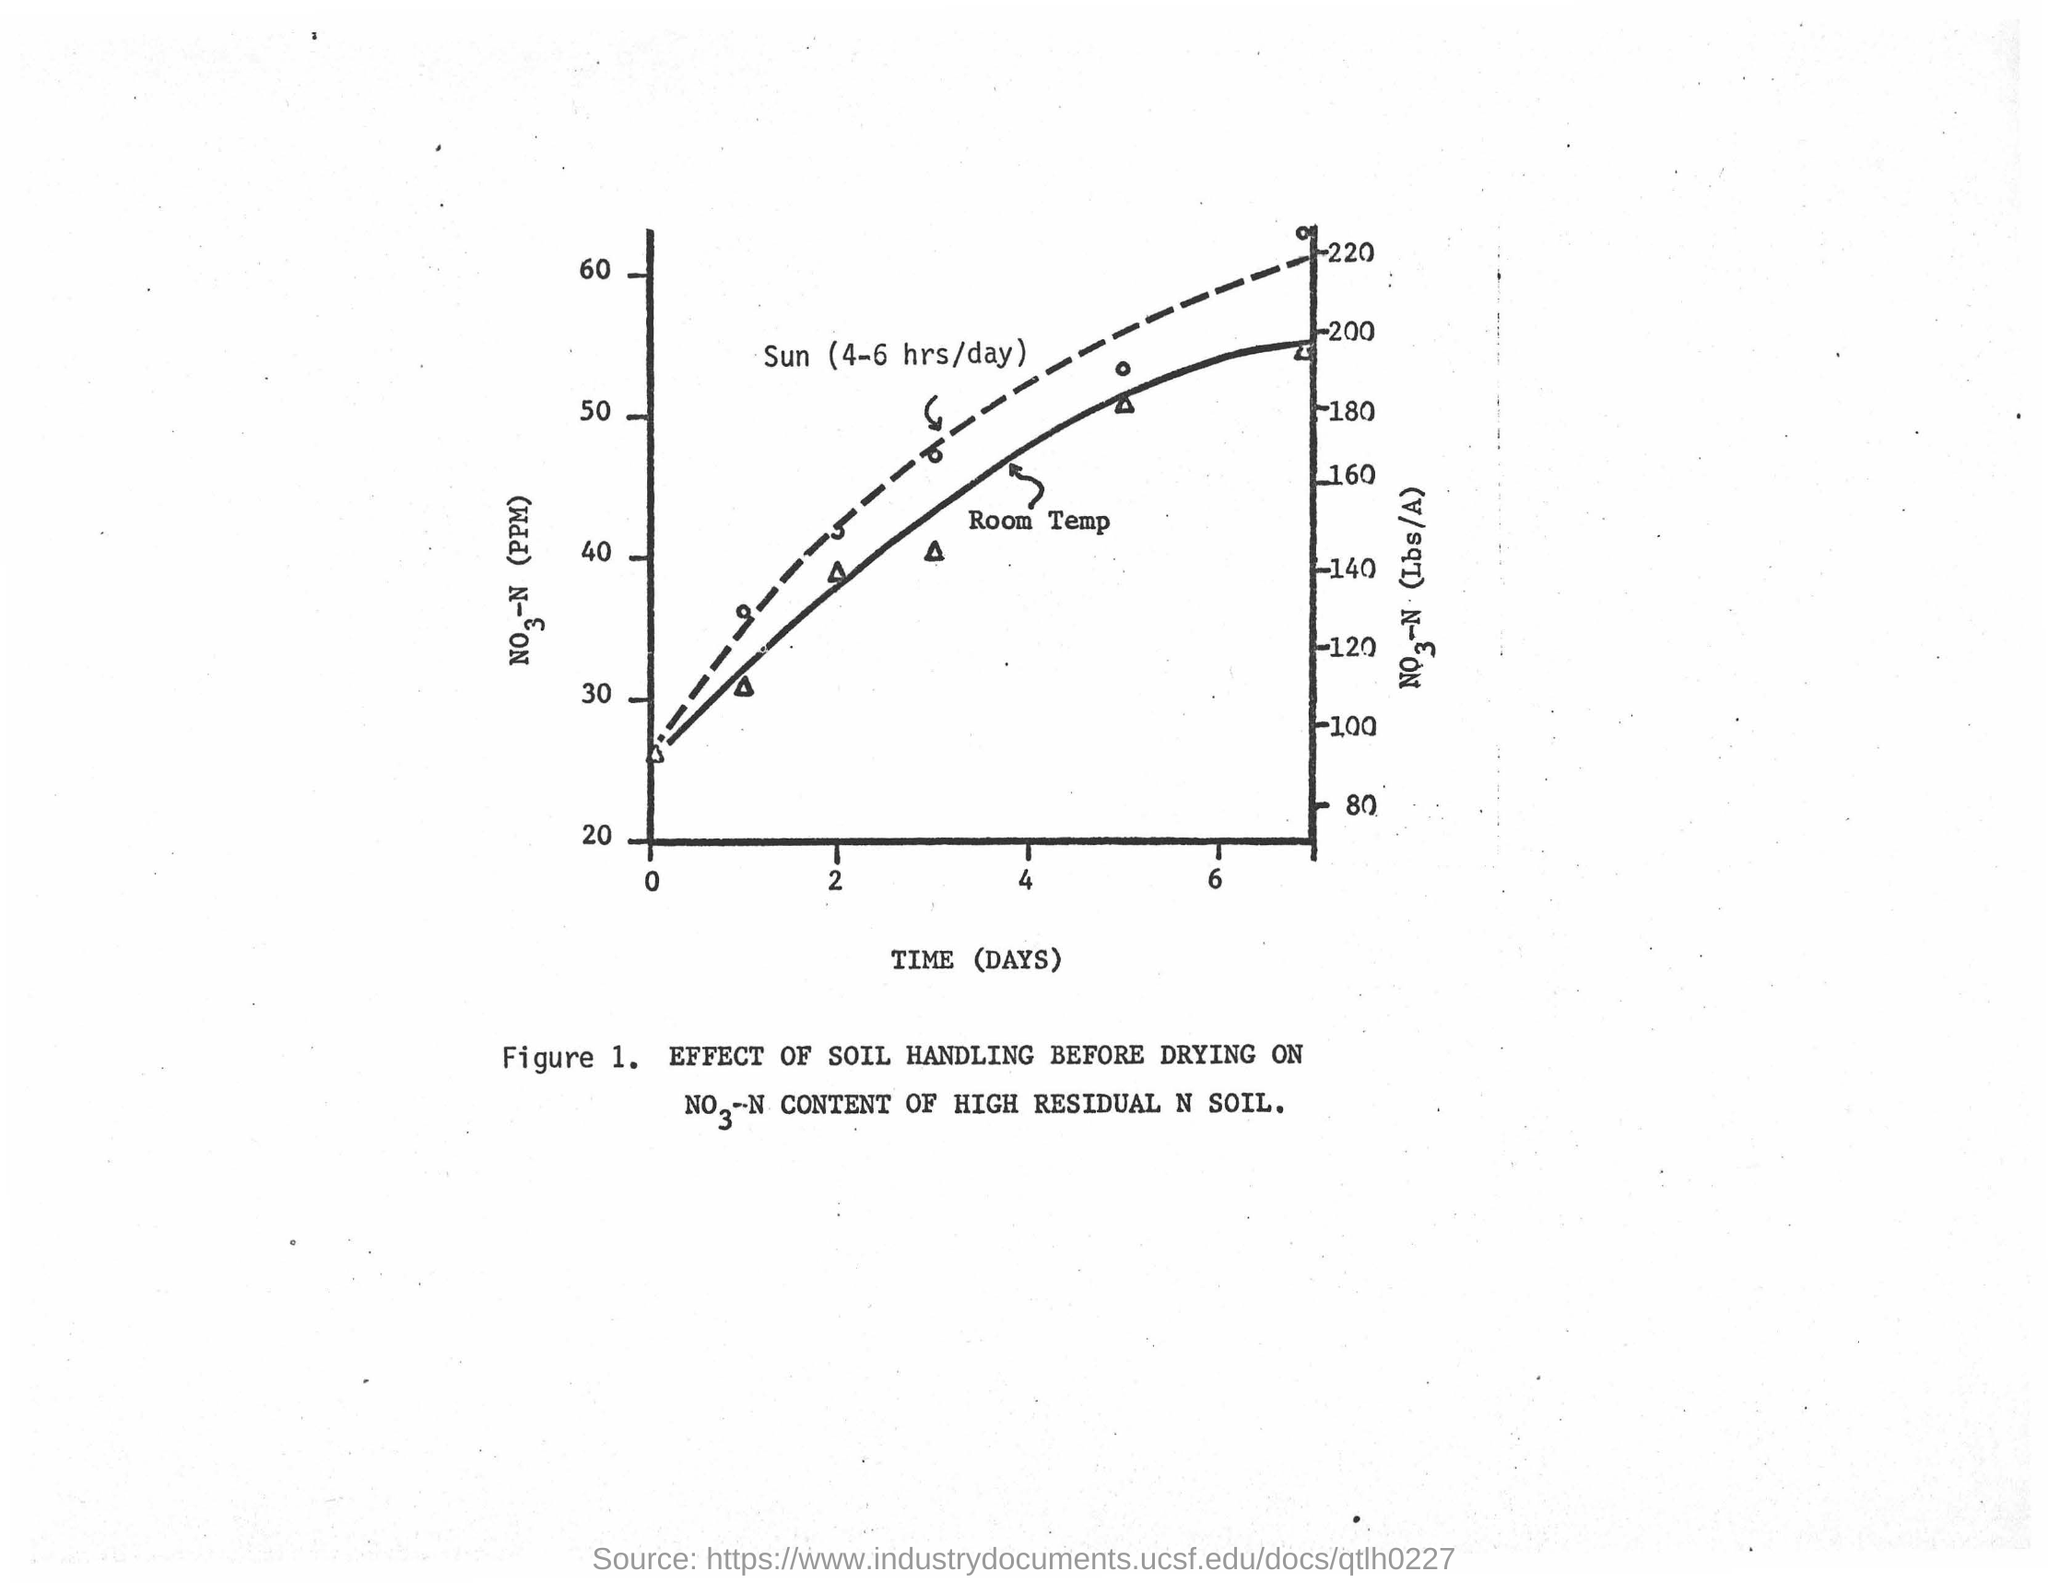Mention a couple of crucial points in this snapshot. The time in the graph is plotted in units of days. 